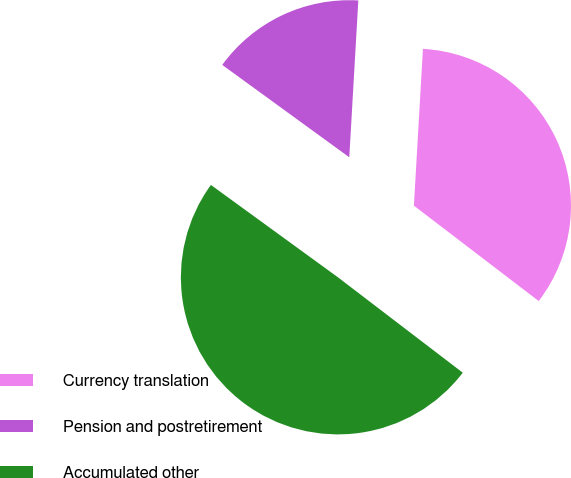Convert chart. <chart><loc_0><loc_0><loc_500><loc_500><pie_chart><fcel>Currency translation<fcel>Pension and postretirement<fcel>Accumulated other<nl><fcel>34.47%<fcel>15.91%<fcel>49.62%<nl></chart> 